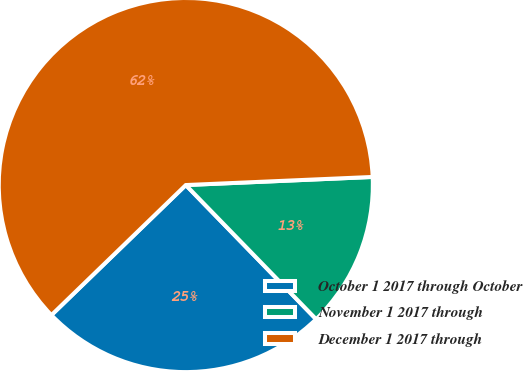Convert chart. <chart><loc_0><loc_0><loc_500><loc_500><pie_chart><fcel>October 1 2017 through October<fcel>November 1 2017 through<fcel>December 1 2017 through<nl><fcel>25.03%<fcel>13.42%<fcel>61.55%<nl></chart> 